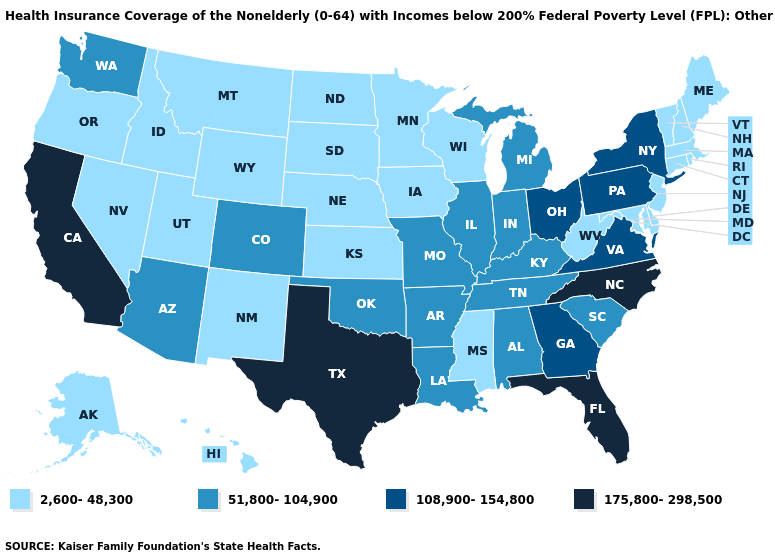Which states have the lowest value in the USA?
Answer briefly. Alaska, Connecticut, Delaware, Hawaii, Idaho, Iowa, Kansas, Maine, Maryland, Massachusetts, Minnesota, Mississippi, Montana, Nebraska, Nevada, New Hampshire, New Jersey, New Mexico, North Dakota, Oregon, Rhode Island, South Dakota, Utah, Vermont, West Virginia, Wisconsin, Wyoming. What is the value of Hawaii?
Answer briefly. 2,600-48,300. What is the highest value in states that border South Carolina?
Short answer required. 175,800-298,500. Among the states that border Virginia , which have the highest value?
Be succinct. North Carolina. Name the states that have a value in the range 51,800-104,900?
Short answer required. Alabama, Arizona, Arkansas, Colorado, Illinois, Indiana, Kentucky, Louisiana, Michigan, Missouri, Oklahoma, South Carolina, Tennessee, Washington. What is the lowest value in the USA?
Keep it brief. 2,600-48,300. Does Oklahoma have the highest value in the USA?
Write a very short answer. No. Does the map have missing data?
Be succinct. No. Does Tennessee have a higher value than Florida?
Concise answer only. No. What is the value of Tennessee?
Keep it brief. 51,800-104,900. Which states have the lowest value in the USA?
Be succinct. Alaska, Connecticut, Delaware, Hawaii, Idaho, Iowa, Kansas, Maine, Maryland, Massachusetts, Minnesota, Mississippi, Montana, Nebraska, Nevada, New Hampshire, New Jersey, New Mexico, North Dakota, Oregon, Rhode Island, South Dakota, Utah, Vermont, West Virginia, Wisconsin, Wyoming. What is the lowest value in the West?
Keep it brief. 2,600-48,300. Does the first symbol in the legend represent the smallest category?
Write a very short answer. Yes. Does Delaware have the same value as Hawaii?
Give a very brief answer. Yes. What is the value of Louisiana?
Short answer required. 51,800-104,900. 